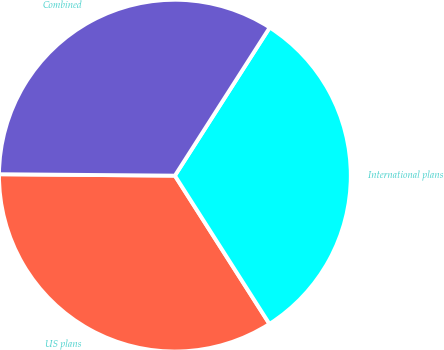<chart> <loc_0><loc_0><loc_500><loc_500><pie_chart><fcel>US plans<fcel>International plans<fcel>Combined<nl><fcel>34.16%<fcel>31.9%<fcel>33.93%<nl></chart> 